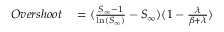<formula> <loc_0><loc_0><loc_500><loc_500>\begin{array} { r l } { O v e r s h o o t } & = ( \frac { S _ { \infty } - 1 } { \ln ( S _ { \infty } ) } - S _ { \infty } ) ( 1 - \frac { \lambda } { \beta + \lambda } ) } \end{array}</formula> 